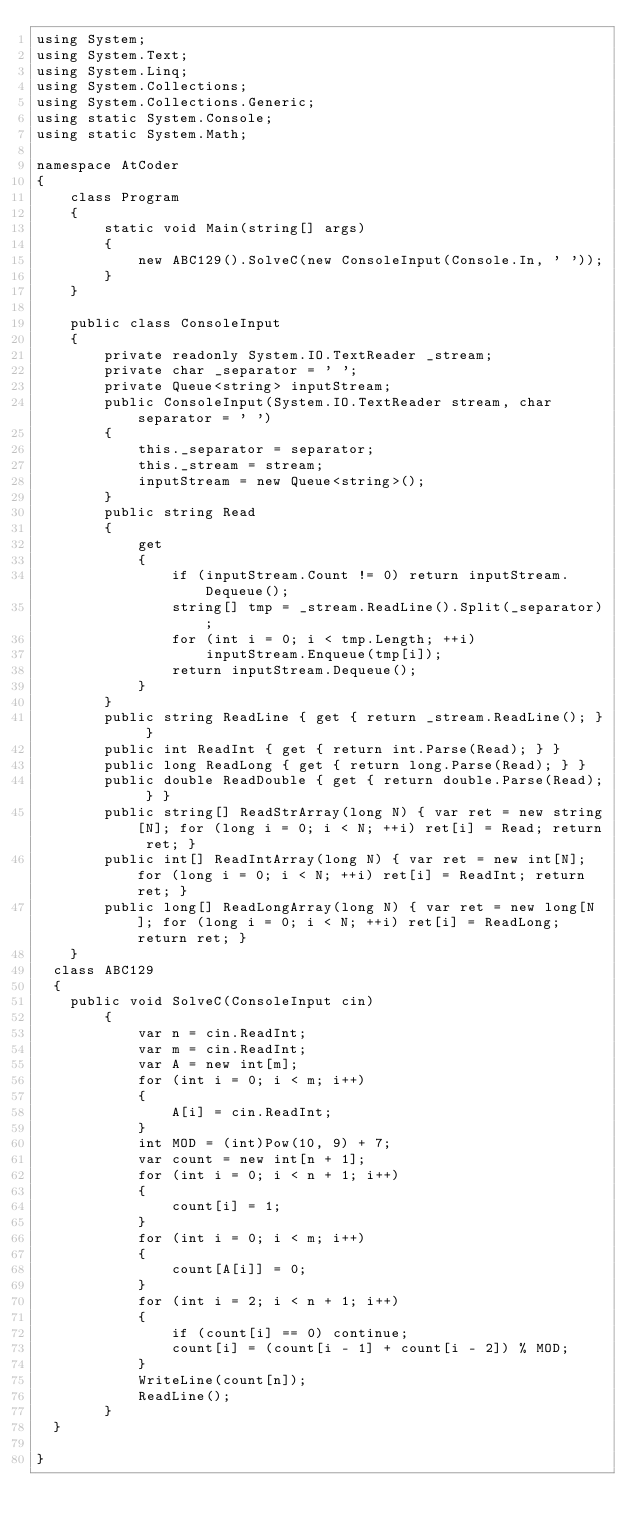Convert code to text. <code><loc_0><loc_0><loc_500><loc_500><_C#_>using System;
using System.Text;
using System.Linq;
using System.Collections;
using System.Collections.Generic;
using static System.Console;
using static System.Math;

namespace AtCoder
{
    class Program
    {
        static void Main(string[] args)
        {
            new ABC129().SolveC(new ConsoleInput(Console.In, ' '));
        }
    }

    public class ConsoleInput
    {
        private readonly System.IO.TextReader _stream;
        private char _separator = ' ';
        private Queue<string> inputStream;
        public ConsoleInput(System.IO.TextReader stream, char separator = ' ')
        {
            this._separator = separator;
            this._stream = stream;
            inputStream = new Queue<string>();
        }
        public string Read
        {
            get
            {
                if (inputStream.Count != 0) return inputStream.Dequeue();
                string[] tmp = _stream.ReadLine().Split(_separator);
                for (int i = 0; i < tmp.Length; ++i)
                    inputStream.Enqueue(tmp[i]);
                return inputStream.Dequeue();
            }
        }
        public string ReadLine { get { return _stream.ReadLine(); } }
        public int ReadInt { get { return int.Parse(Read); } }
        public long ReadLong { get { return long.Parse(Read); } }
        public double ReadDouble { get { return double.Parse(Read); } }
        public string[] ReadStrArray(long N) { var ret = new string[N]; for (long i = 0; i < N; ++i) ret[i] = Read; return ret; }
        public int[] ReadIntArray(long N) { var ret = new int[N]; for (long i = 0; i < N; ++i) ret[i] = ReadInt; return ret; }
        public long[] ReadLongArray(long N) { var ret = new long[N]; for (long i = 0; i < N; ++i) ret[i] = ReadLong; return ret; }
    }
  class ABC129
  {
  	public void SolveC(ConsoleInput cin)
        {
            var n = cin.ReadInt;
            var m = cin.ReadInt;
            var A = new int[m];
            for (int i = 0; i < m; i++)
            {
                A[i] = cin.ReadInt;
            }
            int MOD = (int)Pow(10, 9) + 7;
            var count = new int[n + 1];
            for (int i = 0; i < n + 1; i++)
            {
                count[i] = 1;
            }
            for (int i = 0; i < m; i++)
            {
                count[A[i]] = 0;
            }
            for (int i = 2; i < n + 1; i++)
            {
                if (count[i] == 0) continue;
                count[i] = (count[i - 1] + count[i - 2]) % MOD;
            }
            WriteLine(count[n]);
            ReadLine();
        }
  }
  
}
</code> 